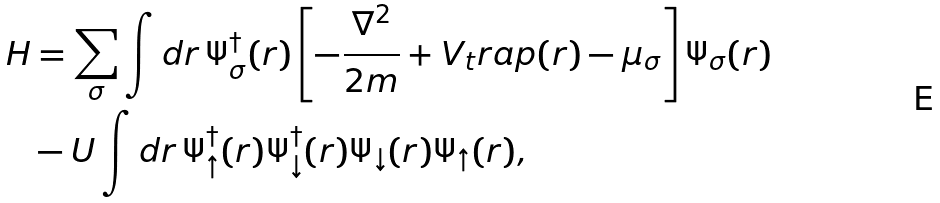<formula> <loc_0><loc_0><loc_500><loc_500>H & = \sum _ { \sigma } \int d { r } \, \Psi _ { \sigma } ^ { \dagger } ( { r } ) \left [ - \frac { \nabla ^ { 2 } } { 2 m } + V _ { t } r a p ( r ) - \mu _ { \sigma } \right ] \Psi _ { \sigma } ( { r } ) \\ & - U \int d { r } \, \Psi _ { \uparrow } ^ { \dagger } ( { r } ) \Psi _ { \downarrow } ^ { \dagger } ( { r } ) \Psi _ { \downarrow } ( { r } ) \Psi _ { \uparrow } ( { r } ) ,</formula> 